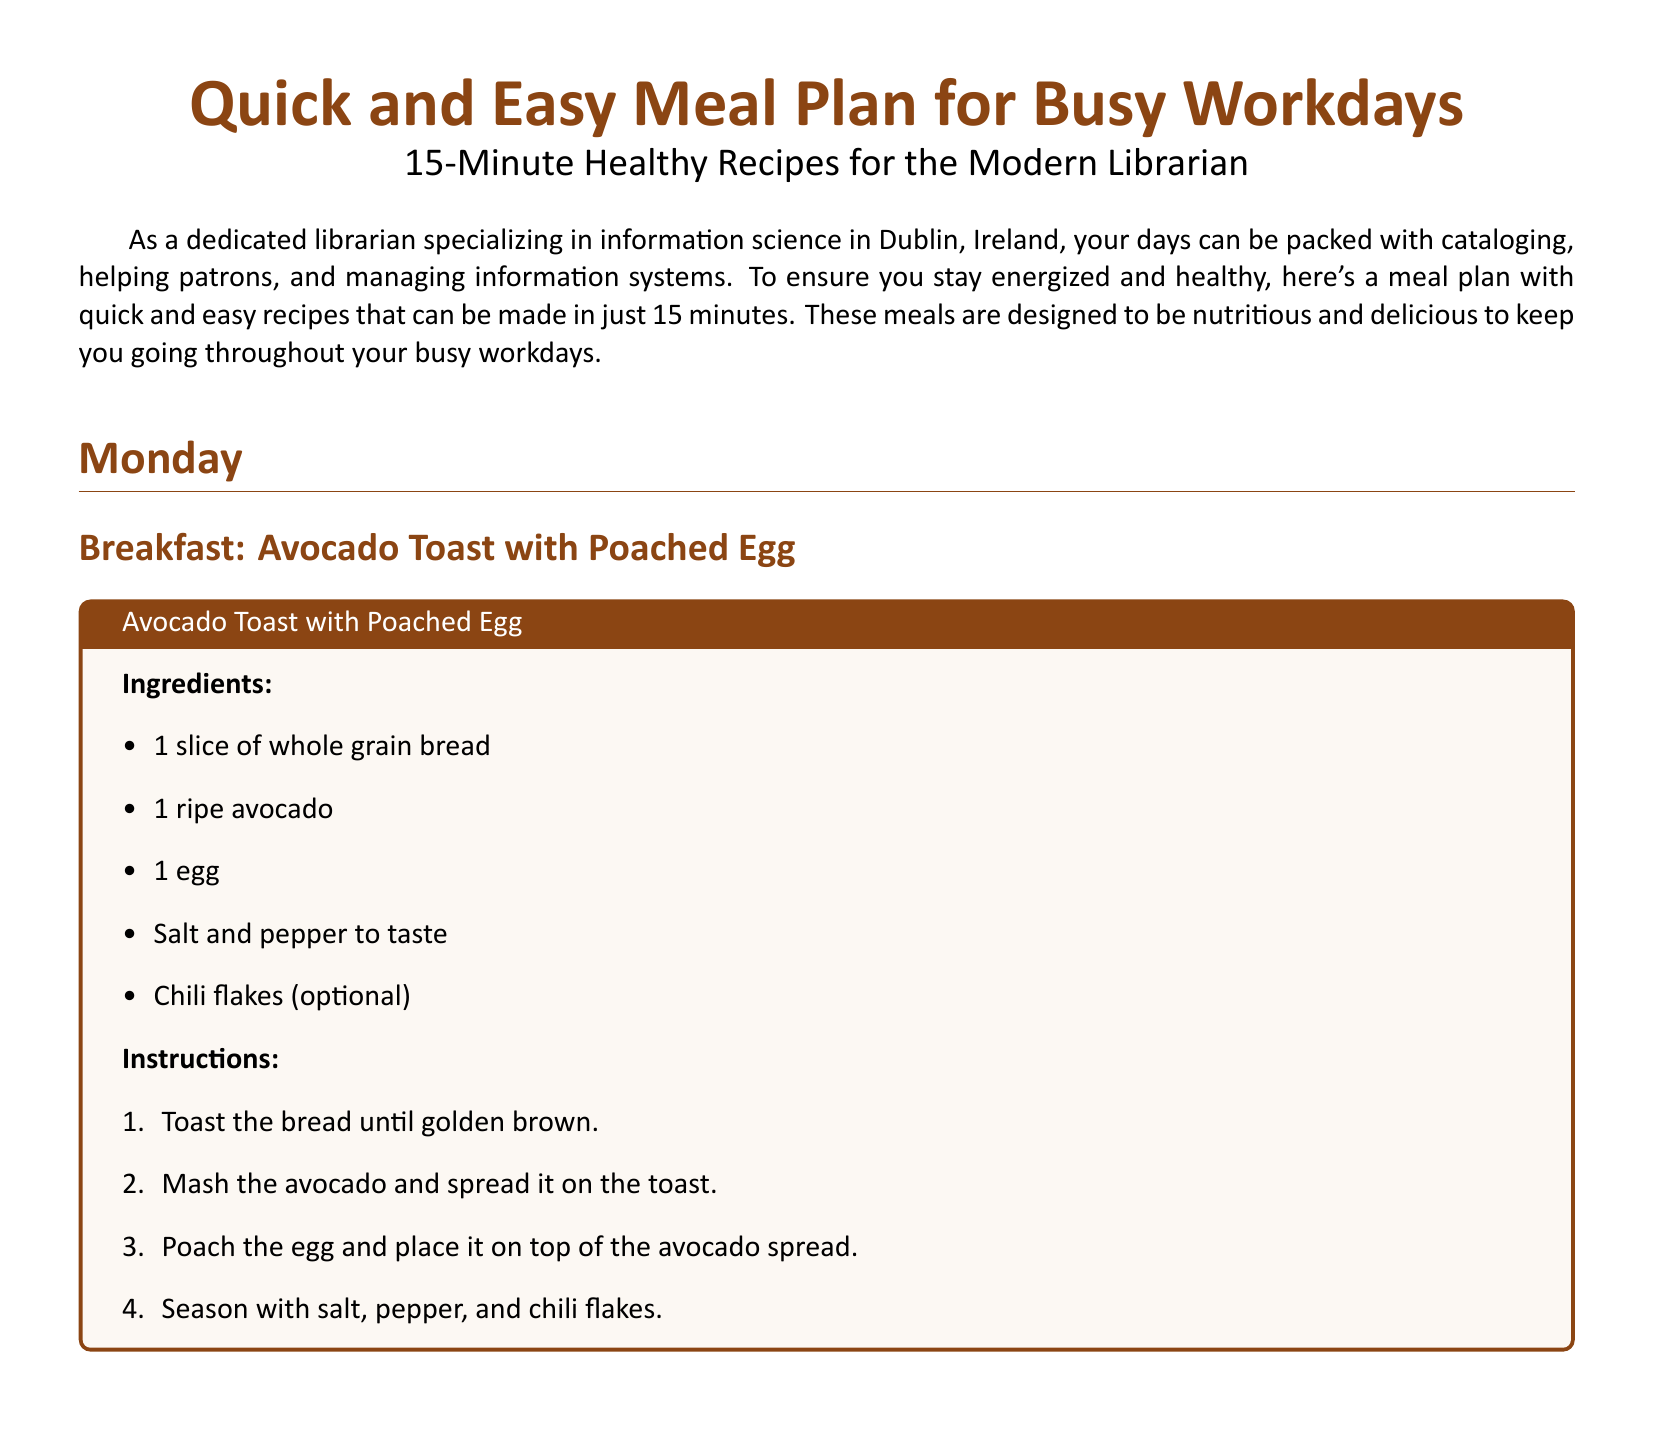What is the title of the document? The title can be found at the top of the document, introducing the meal plan for busy workdays.
Answer: Quick and Easy Meal Plan for Busy Workdays How long does each recipe take to prepare? The document emphasizes quick meals designed for busy schedules, stating the preparation time.
Answer: 15 minutes What is the main ingredient in the breakfast recipe? The breakfast recipe lists avocado as a key component among other ingredients.
Answer: Avocado How many ingredients are needed for the Quick Quinoa Salad? By counting the items listed under the Quick Quinoa Salad recipe in the document, one can find the total.
Answer: 8 ingredients What type of cheese is used in the Quick Quinoa Salad? The recipe specifies the type of cheese among the ingredients for the salad.
Answer: Feta cheese Which meal includes tofu? The document details different meals, and the dinner recipe explicitly mentions tofu as an ingredient.
Answer: Stir-Fried Veggies with Tofu What cooking method is used for the breakfast dish? The instructions outline how to prepare the breakfast meal using a specific technique.
Answer: Poached What vegetable mixture is suggested for the stir-fry? The ingredients section of the stir-fried dish specifies the vegetables included.
Answer: Bell peppers, broccoli, carrots How is the quinoa salad dressed? The instructions for the salad recipe indicate how it is seasoned and dressed.
Answer: Olive oil and lemon juice 